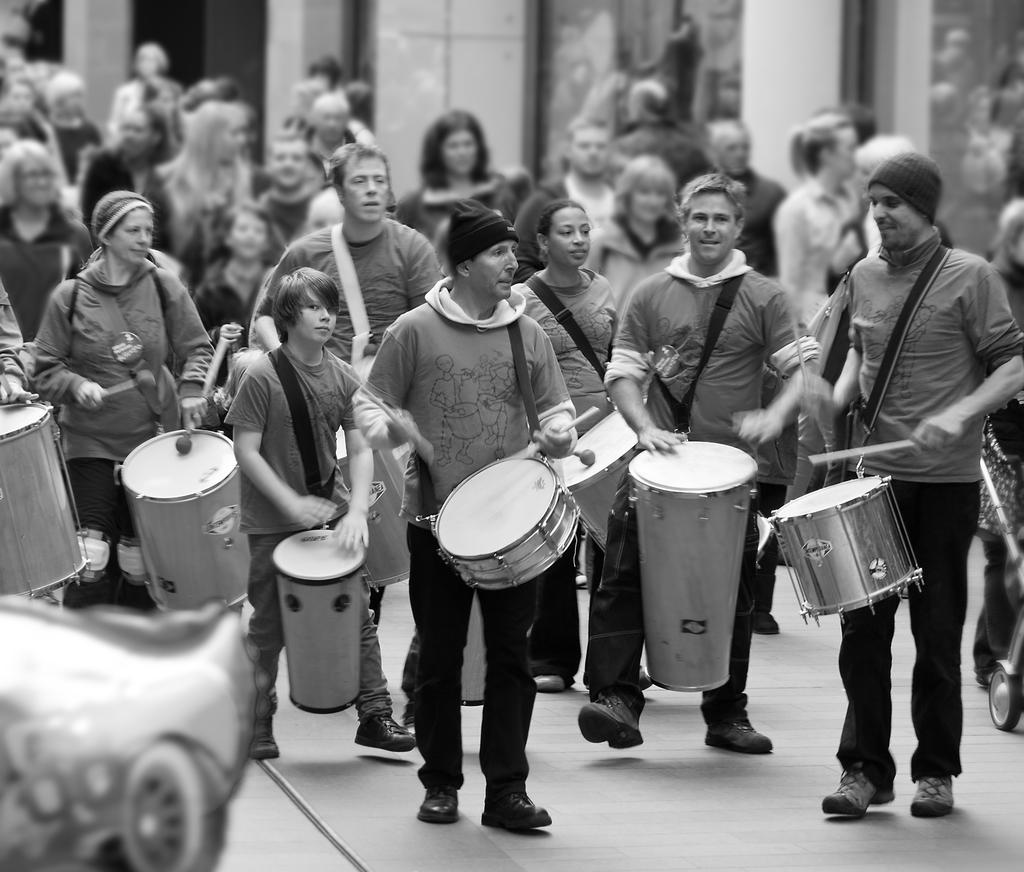What is happening in the image? There is a group of people in the image, and they are walking on a road. What are the people doing while walking on the road? The people are playing musical instruments. What type of slope can be seen in the image? There is no slope present in the image; it features a group of people walking on a road and playing musical instruments. 